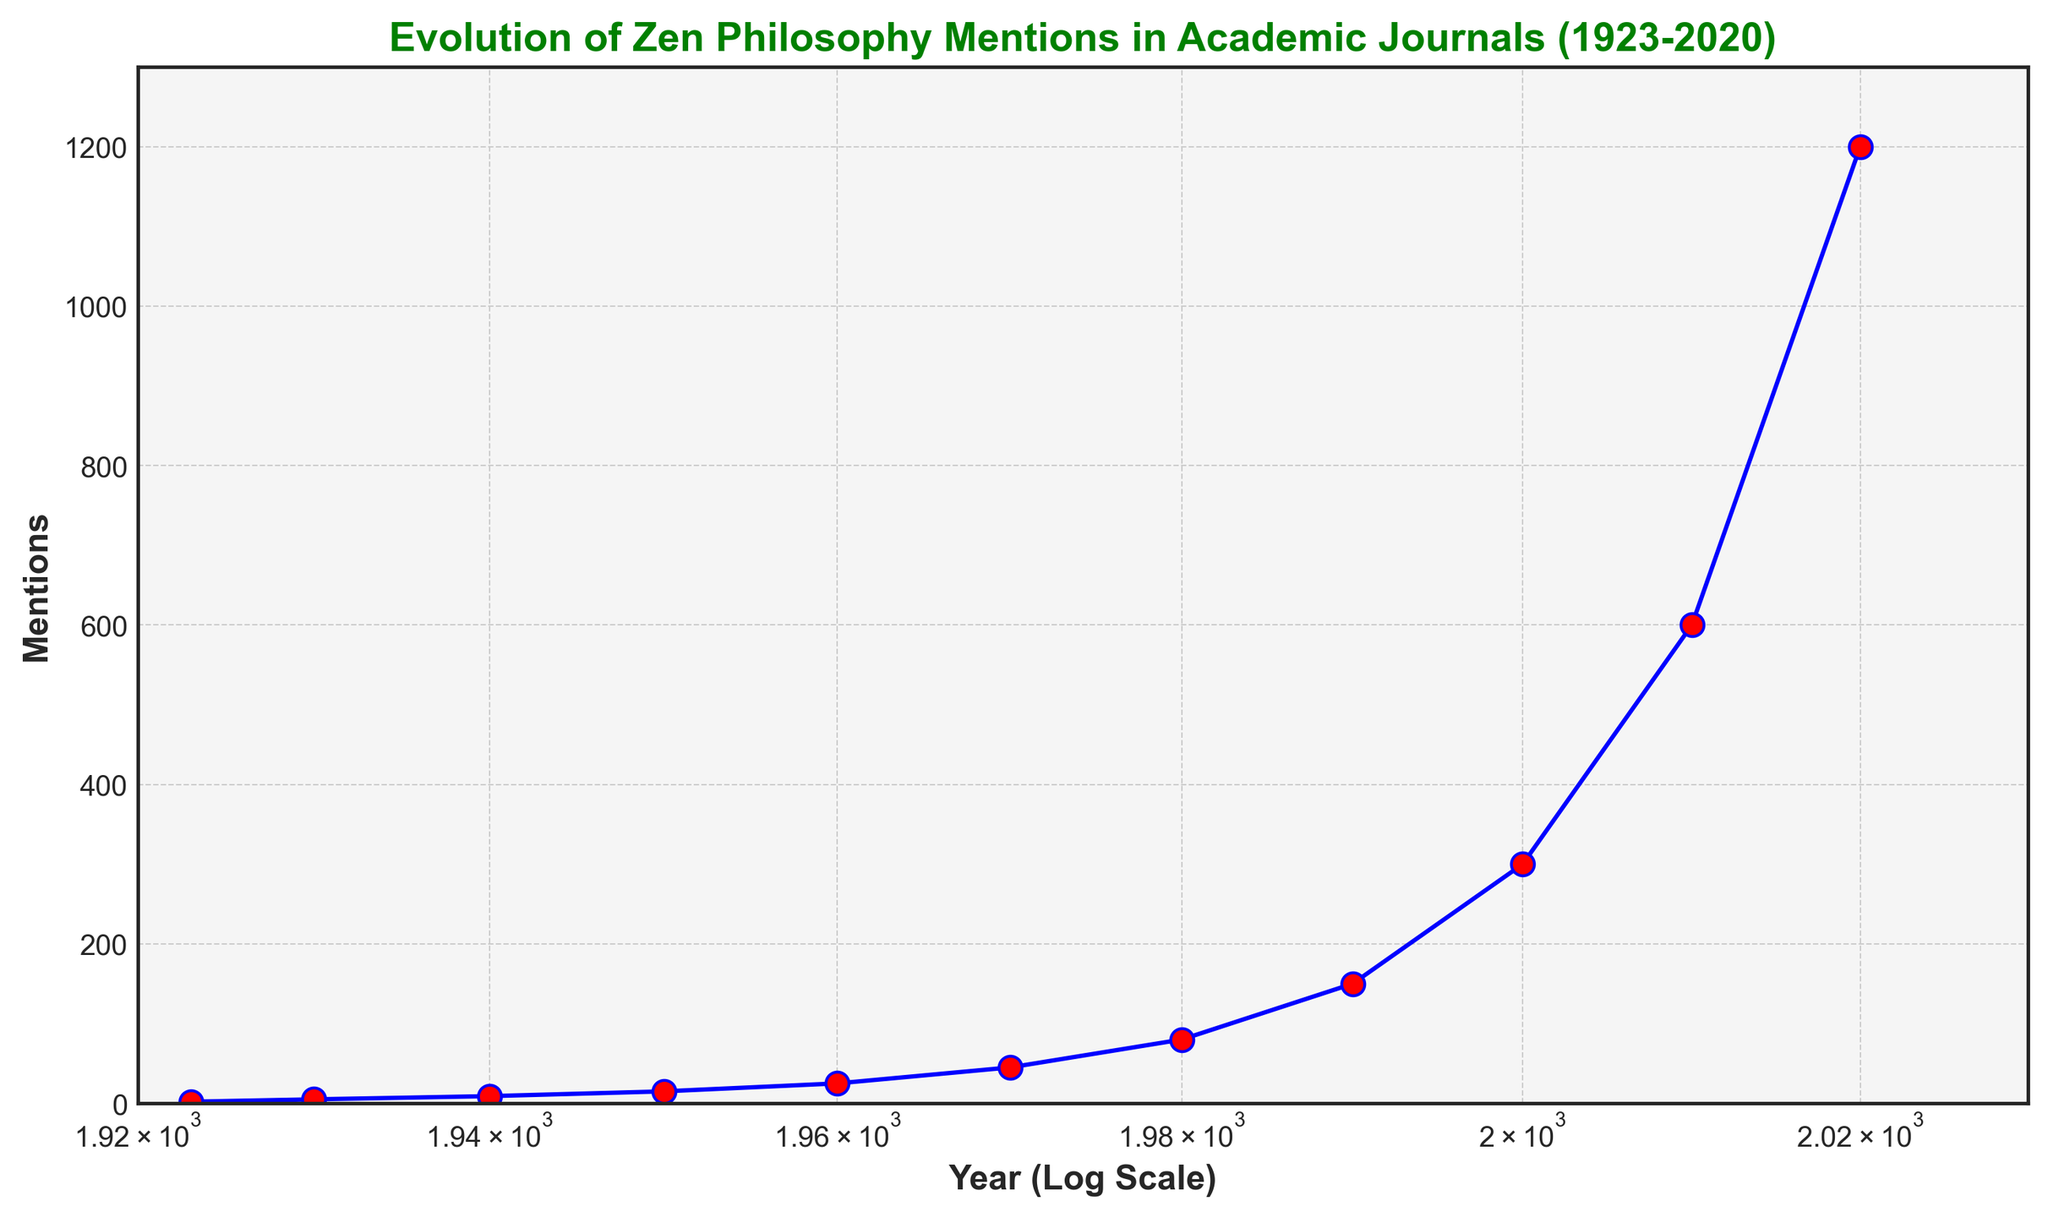How has the number of mentions of Zen philosophy in academic journals evolved between 1950 and 2020? To answer this, we look at the data points for the years 1950 and 2020. In 1950, there were 15 mentions, and in 2020, there were 1200 mentions. The mentions have increased significantly from 15 to 1200 over this period.
Answer: It increased from 15 to 1200 What is the approximate doubling period for the number of mentions from 1950 to 2020? In 1950, the mentions were 15; by 1960, they were 25, and by 1970, they were 45. Roughly, the mentions doubled every decade. From 15 in 1950, to around 600 in 2010, which shows a pattern where the number of mentions roughly doubles every decade.
Answer: Roughly every decade What is the percentage increase in mentions from 1990 to 2000? In 1990, there were 150 mentions, and in 2000, there were 300 mentions. The percentage increase can be calculated as ((300 - 150) / 150) * 100 = 100%.
Answer: 100% How does the trend of mentions before and after 1970 compare? Before 1970, the increase in mentions is gradual: from 2 in 1923 to 45 in 1970. After 1970, the increase is more rapid, reaching 1200 in 2020. Thus, the trend after 1970 shows a steeper rise compared to the period before 1970.
Answer: Steeper rise after 1970 During which decade did the number of mentions cross the 100 mark? By looking at the data points, we can observe that the mentions were 80 in 1980 and then 150 in 1990, which means the mentions crossed the 100 mark sometime in the 1980s.
Answer: 1980s What's the difference in mentions between 1980 and 1990? According to the data, the mentions in 1980 were 80, and in 1990, it was 150. The difference is calculated as 150 - 80 = 70.
Answer: 70 How do the mentions in 1940 compare to mentions in 1923? In 1940, the mentions were 9, while in 1923, there were only 2 mentions. Therefore, the mentions in 1940 were significantly higher than in 1923.
Answer: Higher in 1940 What general trend does the figure show in terms of the growth of Zen philosophy mentions over the last century? Examining the figure shows a clear upward trajectory across the years, with growth accelerating especially from the latter half of the century. This implies steady and significant increasing interest in Zen philosophy in academic journals over time.
Answer: Increasing trend How is the year 1960 marked visually on the plot? The data point for the year 1960 is marked with a blue line connecting to a red marker, showing 25 mentions. The x-axis being on a log scale, makes this visually distinct compared to other linear scales.
Answer: Blue line, red marker 